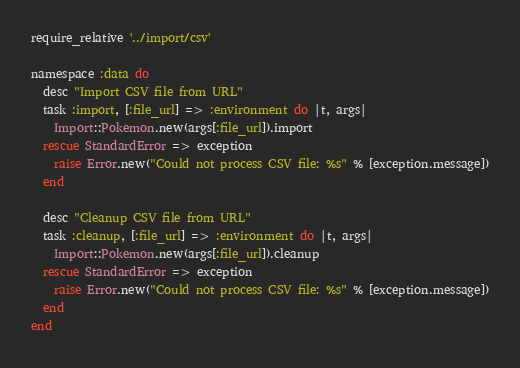<code> <loc_0><loc_0><loc_500><loc_500><_Ruby_>require_relative '../import/csv'

namespace :data do
  desc "Import CSV file from URL"
  task :import, [:file_url] => :environment do |t, args|
    Import::Pokemon.new(args[:file_url]).import
  rescue StandardError => exception
    raise Error.new("Could not process CSV file: %s" % [exception.message])
  end

  desc "Cleanup CSV file from URL"
  task :cleanup, [:file_url] => :environment do |t, args|
    Import::Pokemon.new(args[:file_url]).cleanup
  rescue StandardError => exception
    raise Error.new("Could not process CSV file: %s" % [exception.message])
  end
end
</code> 